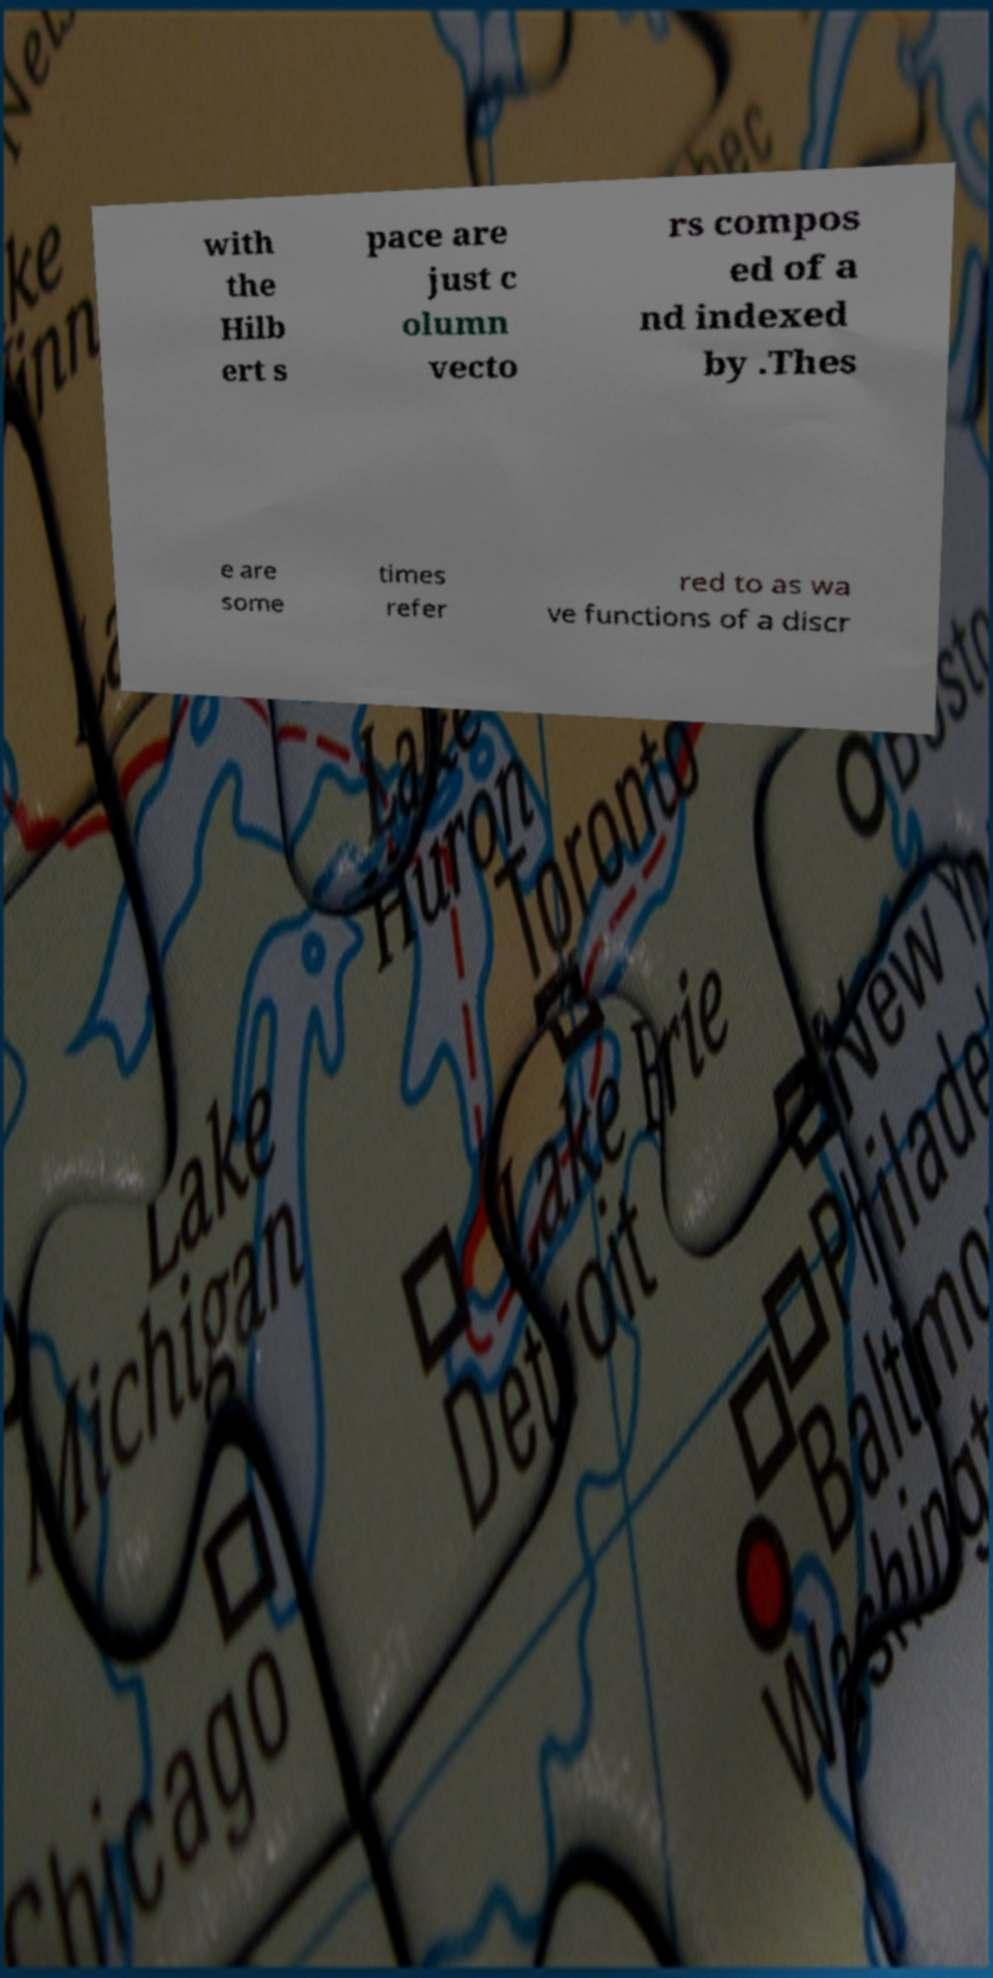What messages or text are displayed in this image? I need them in a readable, typed format. with the Hilb ert s pace are just c olumn vecto rs compos ed of a nd indexed by .Thes e are some times refer red to as wa ve functions of a discr 